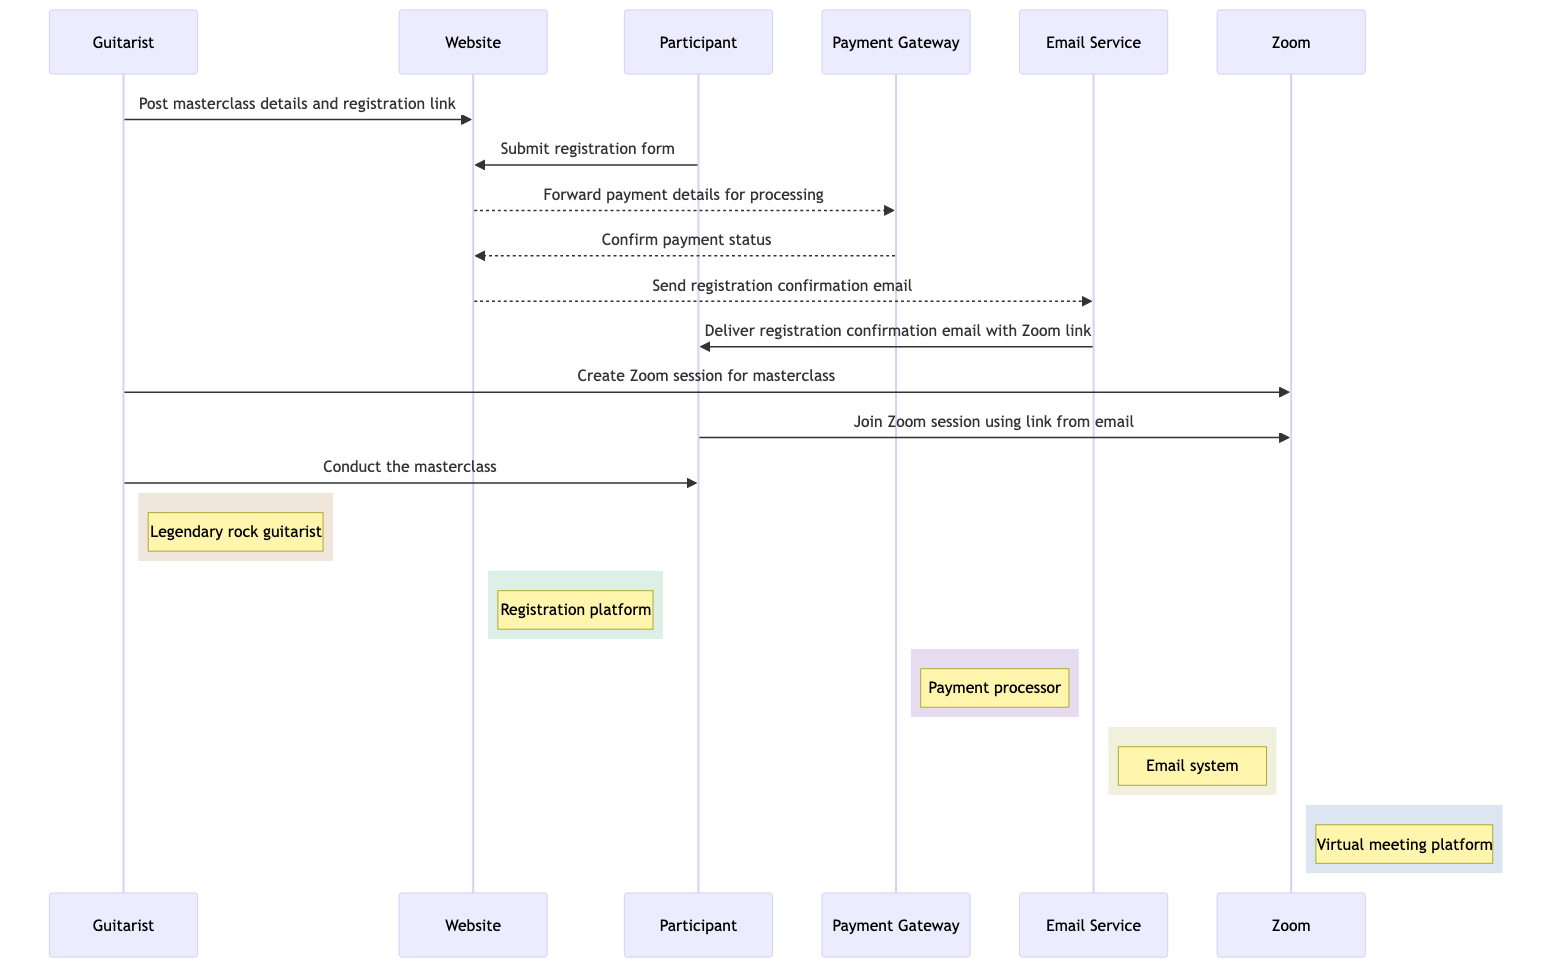What is the first action taken by the Guitarist? The first action taken by the Guitarist is to post masterclass details and the registration link on the Website. This can be seen as the initial step in the sequence diagram where the Guitarist communicates with the Website.
Answer: Post masterclass details and registration link How many participants are involved in this sequence? The sequence diagram involves five participants: Guitarist, Website, Participant, Payment Gateway, Email Service, and Zoom. Counting each distinct participant identifies the total number.
Answer: Five What does the Website do after receiving the registration form? After receiving the registration form from the Participant, the Website forwards payment details for processing to the Payment Gateway, which is the next logical step in the flow.
Answer: Forward payment details for processing What is sent to the Participant after payment status confirmation? After confirming the payment status, the Website sends a registration confirmation email to the Email Service. The sequence then details that this email is delivered to the Participant.
Answer: Registration confirmation email What is the purpose of the Email Service in this sequence? The Email Service's purpose in this sequence is to send the registration confirmation email, which includes the Zoom link. This highlights the function of the Email Service in supporting communication.
Answer: Send registration confirmation email How many messages involve asynchronous communication? In the sequence, there are three messages that involve asynchronous communication: the forwarding of payment details, the payment status confirmation, and the sending of the confirmation email. This will require counting occurrences marked as async.
Answer: Three Who conducts the masterclass? The Guitarist conducts the masterclass, as indicated in the last action of the sequence where he actively participates by leading the session for the Participants.
Answer: Conduct the masterclass What happens after the Participant joins the Zoom session? After the Participant joins the Zoom session using the link from the email, the Guitarist conducts the masterclass, which is the final step indicating the execution of the session.
Answer: Conduct the masterclass What action does the Guitarist take last in the sequence? The last action taken by the Guitarist in this sequence is to conduct the masterclass, concluding the interactions outlined.
Answer: Conduct the masterclass 